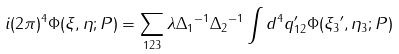<formula> <loc_0><loc_0><loc_500><loc_500>i ( 2 \pi ) ^ { 4 } \Phi ( \xi , \eta ; P ) = \sum _ { 1 2 3 } \lambda { \Delta _ { 1 } } ^ { - 1 } { \Delta _ { 2 } } ^ { - 1 } \int d ^ { 4 } q _ { 1 2 } ^ { \prime } \Phi ( { \xi _ { 3 } } ^ { \prime } , { \eta _ { 3 } } ; P )</formula> 